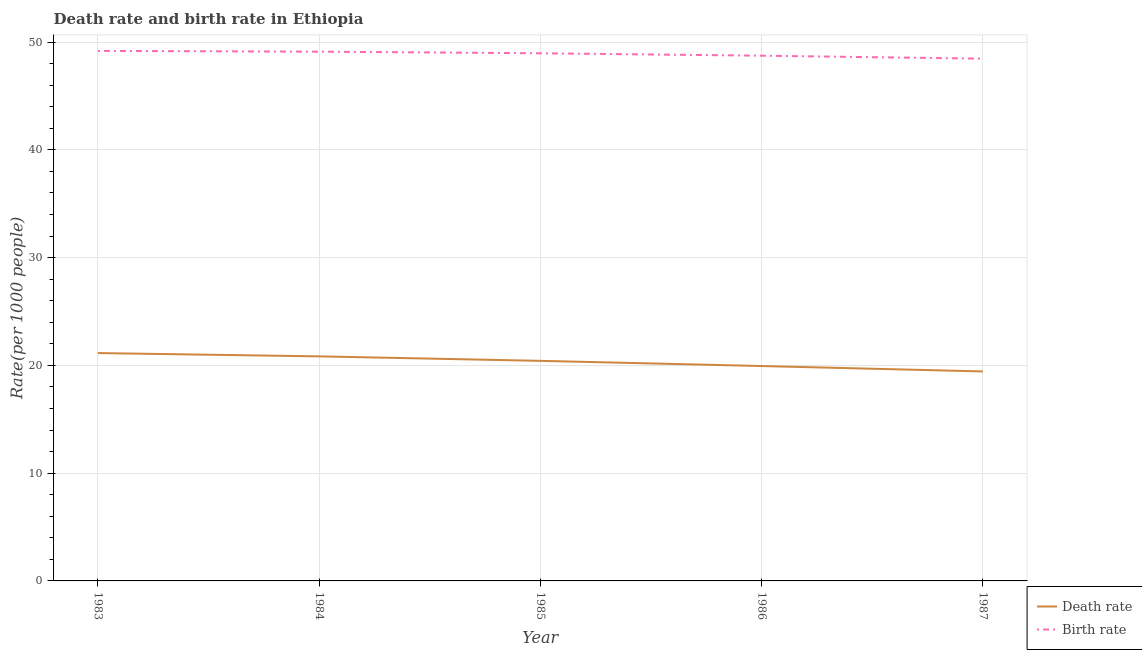How many different coloured lines are there?
Offer a very short reply. 2. Does the line corresponding to birth rate intersect with the line corresponding to death rate?
Make the answer very short. No. Is the number of lines equal to the number of legend labels?
Your response must be concise. Yes. What is the death rate in 1983?
Ensure brevity in your answer.  21.14. Across all years, what is the maximum death rate?
Provide a short and direct response. 21.14. Across all years, what is the minimum birth rate?
Your answer should be compact. 48.46. In which year was the birth rate minimum?
Make the answer very short. 1987. What is the total birth rate in the graph?
Provide a succinct answer. 244.46. What is the difference between the death rate in 1984 and that in 1985?
Provide a succinct answer. 0.41. What is the difference between the birth rate in 1984 and the death rate in 1987?
Keep it short and to the point. 29.67. What is the average death rate per year?
Your response must be concise. 20.36. In the year 1983, what is the difference between the birth rate and death rate?
Provide a short and direct response. 28.04. What is the ratio of the death rate in 1984 to that in 1985?
Give a very brief answer. 1.02. What is the difference between the highest and the second highest birth rate?
Ensure brevity in your answer.  0.07. What is the difference between the highest and the lowest death rate?
Offer a very short reply. 1.7. Does the birth rate monotonically increase over the years?
Make the answer very short. No. Is the birth rate strictly greater than the death rate over the years?
Make the answer very short. Yes. How many lines are there?
Your answer should be very brief. 2. Are the values on the major ticks of Y-axis written in scientific E-notation?
Offer a terse response. No. Where does the legend appear in the graph?
Offer a very short reply. Bottom right. How many legend labels are there?
Provide a short and direct response. 2. How are the legend labels stacked?
Make the answer very short. Vertical. What is the title of the graph?
Offer a very short reply. Death rate and birth rate in Ethiopia. Does "Not attending school" appear as one of the legend labels in the graph?
Keep it short and to the point. No. What is the label or title of the X-axis?
Your answer should be compact. Year. What is the label or title of the Y-axis?
Keep it short and to the point. Rate(per 1000 people). What is the Rate(per 1000 people) of Death rate in 1983?
Provide a succinct answer. 21.14. What is the Rate(per 1000 people) of Birth rate in 1983?
Provide a succinct answer. 49.18. What is the Rate(per 1000 people) in Death rate in 1984?
Keep it short and to the point. 20.84. What is the Rate(per 1000 people) of Birth rate in 1984?
Keep it short and to the point. 49.11. What is the Rate(per 1000 people) of Death rate in 1985?
Make the answer very short. 20.42. What is the Rate(per 1000 people) of Birth rate in 1985?
Offer a terse response. 48.96. What is the Rate(per 1000 people) of Death rate in 1986?
Your answer should be very brief. 19.94. What is the Rate(per 1000 people) in Birth rate in 1986?
Offer a terse response. 48.74. What is the Rate(per 1000 people) in Death rate in 1987?
Provide a short and direct response. 19.44. What is the Rate(per 1000 people) in Birth rate in 1987?
Keep it short and to the point. 48.46. Across all years, what is the maximum Rate(per 1000 people) in Death rate?
Keep it short and to the point. 21.14. Across all years, what is the maximum Rate(per 1000 people) in Birth rate?
Offer a very short reply. 49.18. Across all years, what is the minimum Rate(per 1000 people) of Death rate?
Your response must be concise. 19.44. Across all years, what is the minimum Rate(per 1000 people) of Birth rate?
Keep it short and to the point. 48.46. What is the total Rate(per 1000 people) in Death rate in the graph?
Ensure brevity in your answer.  101.78. What is the total Rate(per 1000 people) of Birth rate in the graph?
Give a very brief answer. 244.46. What is the difference between the Rate(per 1000 people) in Death rate in 1983 and that in 1984?
Offer a very short reply. 0.31. What is the difference between the Rate(per 1000 people) of Birth rate in 1983 and that in 1984?
Make the answer very short. 0.07. What is the difference between the Rate(per 1000 people) of Death rate in 1983 and that in 1985?
Keep it short and to the point. 0.72. What is the difference between the Rate(per 1000 people) in Birth rate in 1983 and that in 1985?
Provide a short and direct response. 0.22. What is the difference between the Rate(per 1000 people) in Death rate in 1983 and that in 1986?
Offer a very short reply. 1.2. What is the difference between the Rate(per 1000 people) of Birth rate in 1983 and that in 1986?
Offer a very short reply. 0.44. What is the difference between the Rate(per 1000 people) in Death rate in 1983 and that in 1987?
Offer a terse response. 1.71. What is the difference between the Rate(per 1000 people) of Birth rate in 1983 and that in 1987?
Your answer should be compact. 0.72. What is the difference between the Rate(per 1000 people) of Death rate in 1984 and that in 1985?
Keep it short and to the point. 0.41. What is the difference between the Rate(per 1000 people) in Birth rate in 1984 and that in 1985?
Give a very brief answer. 0.15. What is the difference between the Rate(per 1000 people) in Death rate in 1984 and that in 1986?
Give a very brief answer. 0.9. What is the difference between the Rate(per 1000 people) in Birth rate in 1984 and that in 1986?
Make the answer very short. 0.37. What is the difference between the Rate(per 1000 people) of Death rate in 1984 and that in 1987?
Your answer should be very brief. 1.4. What is the difference between the Rate(per 1000 people) of Birth rate in 1984 and that in 1987?
Provide a succinct answer. 0.65. What is the difference between the Rate(per 1000 people) of Death rate in 1985 and that in 1986?
Keep it short and to the point. 0.48. What is the difference between the Rate(per 1000 people) in Birth rate in 1985 and that in 1986?
Your answer should be very brief. 0.22. What is the difference between the Rate(per 1000 people) of Birth rate in 1985 and that in 1987?
Make the answer very short. 0.5. What is the difference between the Rate(per 1000 people) in Death rate in 1986 and that in 1987?
Your answer should be very brief. 0.5. What is the difference between the Rate(per 1000 people) in Birth rate in 1986 and that in 1987?
Your answer should be compact. 0.28. What is the difference between the Rate(per 1000 people) in Death rate in 1983 and the Rate(per 1000 people) in Birth rate in 1984?
Provide a succinct answer. -27.97. What is the difference between the Rate(per 1000 people) in Death rate in 1983 and the Rate(per 1000 people) in Birth rate in 1985?
Offer a very short reply. -27.82. What is the difference between the Rate(per 1000 people) of Death rate in 1983 and the Rate(per 1000 people) of Birth rate in 1986?
Provide a succinct answer. -27.59. What is the difference between the Rate(per 1000 people) in Death rate in 1983 and the Rate(per 1000 people) in Birth rate in 1987?
Offer a terse response. -27.32. What is the difference between the Rate(per 1000 people) of Death rate in 1984 and the Rate(per 1000 people) of Birth rate in 1985?
Keep it short and to the point. -28.13. What is the difference between the Rate(per 1000 people) of Death rate in 1984 and the Rate(per 1000 people) of Birth rate in 1986?
Make the answer very short. -27.9. What is the difference between the Rate(per 1000 people) in Death rate in 1984 and the Rate(per 1000 people) in Birth rate in 1987?
Provide a succinct answer. -27.62. What is the difference between the Rate(per 1000 people) in Death rate in 1985 and the Rate(per 1000 people) in Birth rate in 1986?
Offer a terse response. -28.32. What is the difference between the Rate(per 1000 people) of Death rate in 1985 and the Rate(per 1000 people) of Birth rate in 1987?
Your answer should be compact. -28.04. What is the difference between the Rate(per 1000 people) in Death rate in 1986 and the Rate(per 1000 people) in Birth rate in 1987?
Provide a succinct answer. -28.52. What is the average Rate(per 1000 people) in Death rate per year?
Offer a very short reply. 20.36. What is the average Rate(per 1000 people) of Birth rate per year?
Your answer should be compact. 48.89. In the year 1983, what is the difference between the Rate(per 1000 people) in Death rate and Rate(per 1000 people) in Birth rate?
Keep it short and to the point. -28.04. In the year 1984, what is the difference between the Rate(per 1000 people) in Death rate and Rate(per 1000 people) in Birth rate?
Provide a short and direct response. -28.28. In the year 1985, what is the difference between the Rate(per 1000 people) in Death rate and Rate(per 1000 people) in Birth rate?
Provide a succinct answer. -28.54. In the year 1986, what is the difference between the Rate(per 1000 people) in Death rate and Rate(per 1000 people) in Birth rate?
Offer a terse response. -28.8. In the year 1987, what is the difference between the Rate(per 1000 people) of Death rate and Rate(per 1000 people) of Birth rate?
Your answer should be very brief. -29.02. What is the ratio of the Rate(per 1000 people) of Death rate in 1983 to that in 1984?
Offer a terse response. 1.01. What is the ratio of the Rate(per 1000 people) in Death rate in 1983 to that in 1985?
Ensure brevity in your answer.  1.04. What is the ratio of the Rate(per 1000 people) in Death rate in 1983 to that in 1986?
Give a very brief answer. 1.06. What is the ratio of the Rate(per 1000 people) of Birth rate in 1983 to that in 1986?
Make the answer very short. 1.01. What is the ratio of the Rate(per 1000 people) in Death rate in 1983 to that in 1987?
Your answer should be very brief. 1.09. What is the ratio of the Rate(per 1000 people) in Birth rate in 1983 to that in 1987?
Offer a terse response. 1.01. What is the ratio of the Rate(per 1000 people) in Death rate in 1984 to that in 1985?
Ensure brevity in your answer.  1.02. What is the ratio of the Rate(per 1000 people) in Death rate in 1984 to that in 1986?
Keep it short and to the point. 1.04. What is the ratio of the Rate(per 1000 people) in Birth rate in 1984 to that in 1986?
Give a very brief answer. 1.01. What is the ratio of the Rate(per 1000 people) of Death rate in 1984 to that in 1987?
Your answer should be very brief. 1.07. What is the ratio of the Rate(per 1000 people) of Birth rate in 1984 to that in 1987?
Make the answer very short. 1.01. What is the ratio of the Rate(per 1000 people) in Death rate in 1985 to that in 1986?
Your answer should be compact. 1.02. What is the ratio of the Rate(per 1000 people) in Death rate in 1985 to that in 1987?
Keep it short and to the point. 1.05. What is the ratio of the Rate(per 1000 people) in Birth rate in 1985 to that in 1987?
Offer a very short reply. 1.01. What is the ratio of the Rate(per 1000 people) of Death rate in 1986 to that in 1987?
Provide a succinct answer. 1.03. What is the ratio of the Rate(per 1000 people) of Birth rate in 1986 to that in 1987?
Keep it short and to the point. 1.01. What is the difference between the highest and the second highest Rate(per 1000 people) of Death rate?
Keep it short and to the point. 0.31. What is the difference between the highest and the second highest Rate(per 1000 people) of Birth rate?
Keep it short and to the point. 0.07. What is the difference between the highest and the lowest Rate(per 1000 people) of Death rate?
Your answer should be compact. 1.71. What is the difference between the highest and the lowest Rate(per 1000 people) in Birth rate?
Make the answer very short. 0.72. 